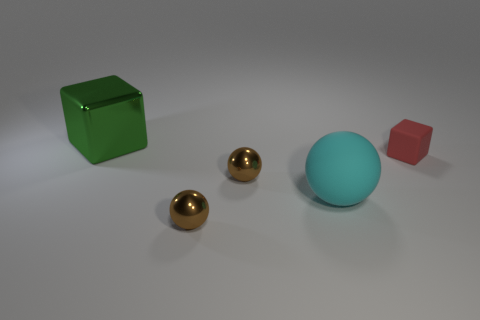Subtract 1 cubes. How many cubes are left? 1 Add 4 metallic things. How many objects exist? 9 Subtract all red blocks. How many blocks are left? 1 Subtract all brown balls. How many balls are left? 1 Add 5 red blocks. How many red blocks are left? 6 Add 5 cyan rubber balls. How many cyan rubber balls exist? 6 Subtract 0 red spheres. How many objects are left? 5 Subtract all cubes. How many objects are left? 3 Subtract all green spheres. Subtract all blue blocks. How many spheres are left? 3 Subtract all gray spheres. How many yellow cubes are left? 0 